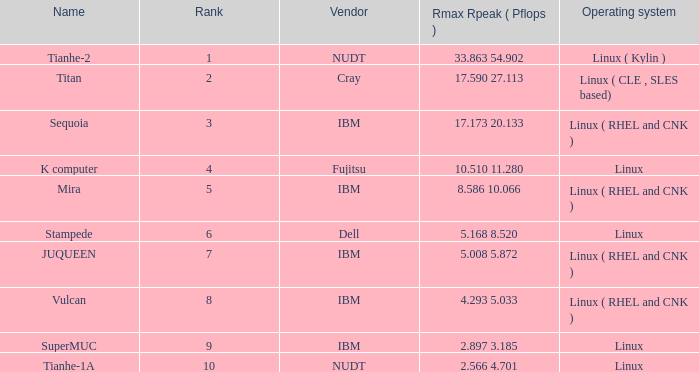What is the name of Rank 5? Mira. 